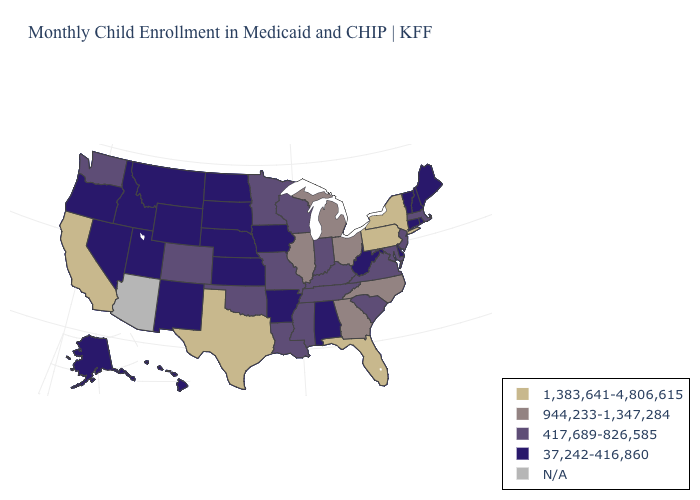Name the states that have a value in the range 417,689-826,585?
Write a very short answer. Colorado, Indiana, Kentucky, Louisiana, Maryland, Massachusetts, Minnesota, Mississippi, Missouri, New Jersey, Oklahoma, South Carolina, Tennessee, Virginia, Washington, Wisconsin. What is the value of Massachusetts?
Keep it brief. 417,689-826,585. Name the states that have a value in the range 37,242-416,860?
Short answer required. Alabama, Alaska, Arkansas, Connecticut, Delaware, Hawaii, Idaho, Iowa, Kansas, Maine, Montana, Nebraska, Nevada, New Hampshire, New Mexico, North Dakota, Oregon, Rhode Island, South Dakota, Utah, Vermont, West Virginia, Wyoming. Name the states that have a value in the range 37,242-416,860?
Keep it brief. Alabama, Alaska, Arkansas, Connecticut, Delaware, Hawaii, Idaho, Iowa, Kansas, Maine, Montana, Nebraska, Nevada, New Hampshire, New Mexico, North Dakota, Oregon, Rhode Island, South Dakota, Utah, Vermont, West Virginia, Wyoming. Name the states that have a value in the range N/A?
Short answer required. Arizona. Which states hav the highest value in the Northeast?
Quick response, please. New York, Pennsylvania. Does Indiana have the lowest value in the USA?
Concise answer only. No. What is the value of Minnesota?
Give a very brief answer. 417,689-826,585. Which states hav the highest value in the West?
Write a very short answer. California. Name the states that have a value in the range 417,689-826,585?
Give a very brief answer. Colorado, Indiana, Kentucky, Louisiana, Maryland, Massachusetts, Minnesota, Mississippi, Missouri, New Jersey, Oklahoma, South Carolina, Tennessee, Virginia, Washington, Wisconsin. Among the states that border Oregon , does Nevada have the lowest value?
Quick response, please. Yes. 